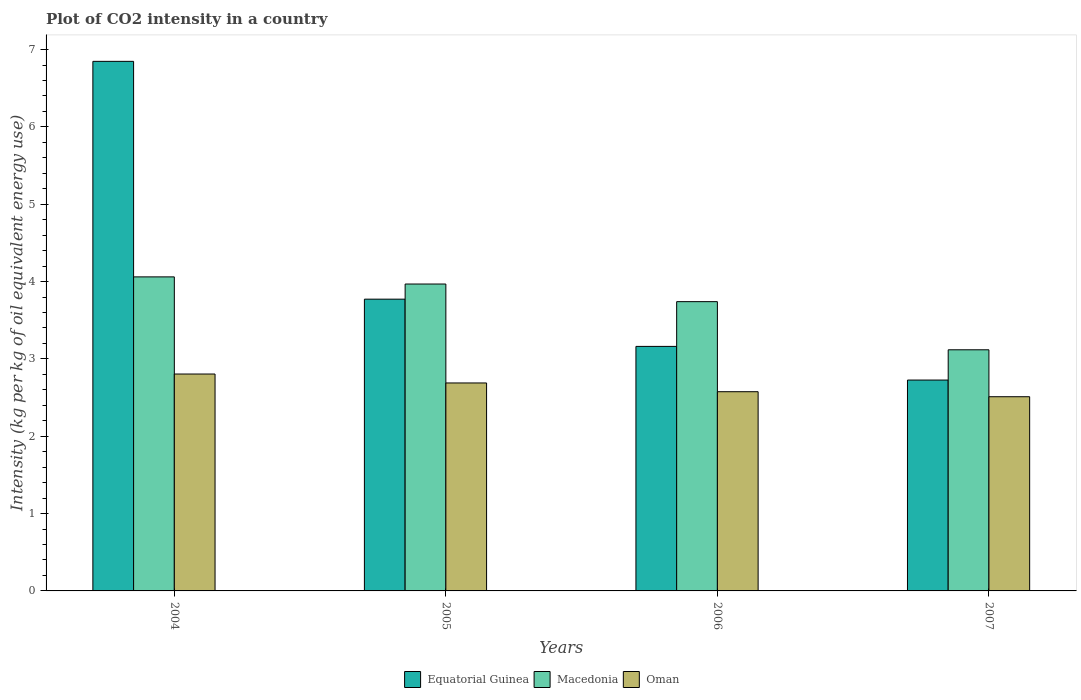How many different coloured bars are there?
Keep it short and to the point. 3. Are the number of bars per tick equal to the number of legend labels?
Your response must be concise. Yes. Are the number of bars on each tick of the X-axis equal?
Make the answer very short. Yes. How many bars are there on the 4th tick from the left?
Provide a succinct answer. 3. What is the CO2 intensity in in Oman in 2007?
Your answer should be compact. 2.51. Across all years, what is the maximum CO2 intensity in in Oman?
Provide a short and direct response. 2.8. Across all years, what is the minimum CO2 intensity in in Macedonia?
Offer a very short reply. 3.12. In which year was the CO2 intensity in in Equatorial Guinea maximum?
Your response must be concise. 2004. What is the total CO2 intensity in in Macedonia in the graph?
Keep it short and to the point. 14.89. What is the difference between the CO2 intensity in in Oman in 2005 and that in 2006?
Offer a terse response. 0.11. What is the difference between the CO2 intensity in in Macedonia in 2007 and the CO2 intensity in in Equatorial Guinea in 2005?
Provide a succinct answer. -0.65. What is the average CO2 intensity in in Oman per year?
Offer a terse response. 2.65. In the year 2007, what is the difference between the CO2 intensity in in Oman and CO2 intensity in in Macedonia?
Your answer should be very brief. -0.61. In how many years, is the CO2 intensity in in Oman greater than 6.8 kg?
Offer a very short reply. 0. What is the ratio of the CO2 intensity in in Equatorial Guinea in 2005 to that in 2006?
Your answer should be compact. 1.19. What is the difference between the highest and the second highest CO2 intensity in in Macedonia?
Keep it short and to the point. 0.09. What is the difference between the highest and the lowest CO2 intensity in in Macedonia?
Ensure brevity in your answer.  0.94. What does the 3rd bar from the left in 2005 represents?
Give a very brief answer. Oman. What does the 3rd bar from the right in 2004 represents?
Make the answer very short. Equatorial Guinea. How many bars are there?
Give a very brief answer. 12. Are all the bars in the graph horizontal?
Your answer should be compact. No. How many years are there in the graph?
Make the answer very short. 4. What is the difference between two consecutive major ticks on the Y-axis?
Offer a very short reply. 1. Does the graph contain grids?
Make the answer very short. No. How many legend labels are there?
Offer a terse response. 3. How are the legend labels stacked?
Your response must be concise. Horizontal. What is the title of the graph?
Your response must be concise. Plot of CO2 intensity in a country. What is the label or title of the Y-axis?
Your answer should be very brief. Intensity (kg per kg of oil equivalent energy use). What is the Intensity (kg per kg of oil equivalent energy use) of Equatorial Guinea in 2004?
Offer a terse response. 6.85. What is the Intensity (kg per kg of oil equivalent energy use) of Macedonia in 2004?
Provide a short and direct response. 4.06. What is the Intensity (kg per kg of oil equivalent energy use) of Oman in 2004?
Make the answer very short. 2.8. What is the Intensity (kg per kg of oil equivalent energy use) of Equatorial Guinea in 2005?
Offer a very short reply. 3.77. What is the Intensity (kg per kg of oil equivalent energy use) in Macedonia in 2005?
Ensure brevity in your answer.  3.97. What is the Intensity (kg per kg of oil equivalent energy use) in Oman in 2005?
Provide a short and direct response. 2.69. What is the Intensity (kg per kg of oil equivalent energy use) of Equatorial Guinea in 2006?
Offer a terse response. 3.16. What is the Intensity (kg per kg of oil equivalent energy use) of Macedonia in 2006?
Your response must be concise. 3.74. What is the Intensity (kg per kg of oil equivalent energy use) of Oman in 2006?
Your answer should be compact. 2.58. What is the Intensity (kg per kg of oil equivalent energy use) of Equatorial Guinea in 2007?
Offer a very short reply. 2.73. What is the Intensity (kg per kg of oil equivalent energy use) of Macedonia in 2007?
Give a very brief answer. 3.12. What is the Intensity (kg per kg of oil equivalent energy use) of Oman in 2007?
Make the answer very short. 2.51. Across all years, what is the maximum Intensity (kg per kg of oil equivalent energy use) in Equatorial Guinea?
Ensure brevity in your answer.  6.85. Across all years, what is the maximum Intensity (kg per kg of oil equivalent energy use) of Macedonia?
Offer a terse response. 4.06. Across all years, what is the maximum Intensity (kg per kg of oil equivalent energy use) of Oman?
Ensure brevity in your answer.  2.8. Across all years, what is the minimum Intensity (kg per kg of oil equivalent energy use) in Equatorial Guinea?
Provide a succinct answer. 2.73. Across all years, what is the minimum Intensity (kg per kg of oil equivalent energy use) of Macedonia?
Your answer should be compact. 3.12. Across all years, what is the minimum Intensity (kg per kg of oil equivalent energy use) of Oman?
Your response must be concise. 2.51. What is the total Intensity (kg per kg of oil equivalent energy use) of Equatorial Guinea in the graph?
Your answer should be very brief. 16.51. What is the total Intensity (kg per kg of oil equivalent energy use) in Macedonia in the graph?
Keep it short and to the point. 14.89. What is the total Intensity (kg per kg of oil equivalent energy use) of Oman in the graph?
Your answer should be compact. 10.58. What is the difference between the Intensity (kg per kg of oil equivalent energy use) of Equatorial Guinea in 2004 and that in 2005?
Offer a very short reply. 3.08. What is the difference between the Intensity (kg per kg of oil equivalent energy use) of Macedonia in 2004 and that in 2005?
Keep it short and to the point. 0.09. What is the difference between the Intensity (kg per kg of oil equivalent energy use) of Oman in 2004 and that in 2005?
Ensure brevity in your answer.  0.12. What is the difference between the Intensity (kg per kg of oil equivalent energy use) in Equatorial Guinea in 2004 and that in 2006?
Your response must be concise. 3.69. What is the difference between the Intensity (kg per kg of oil equivalent energy use) of Macedonia in 2004 and that in 2006?
Keep it short and to the point. 0.32. What is the difference between the Intensity (kg per kg of oil equivalent energy use) in Oman in 2004 and that in 2006?
Your answer should be compact. 0.23. What is the difference between the Intensity (kg per kg of oil equivalent energy use) in Equatorial Guinea in 2004 and that in 2007?
Provide a succinct answer. 4.12. What is the difference between the Intensity (kg per kg of oil equivalent energy use) in Macedonia in 2004 and that in 2007?
Provide a short and direct response. 0.94. What is the difference between the Intensity (kg per kg of oil equivalent energy use) of Oman in 2004 and that in 2007?
Keep it short and to the point. 0.29. What is the difference between the Intensity (kg per kg of oil equivalent energy use) in Equatorial Guinea in 2005 and that in 2006?
Ensure brevity in your answer.  0.61. What is the difference between the Intensity (kg per kg of oil equivalent energy use) of Macedonia in 2005 and that in 2006?
Provide a short and direct response. 0.23. What is the difference between the Intensity (kg per kg of oil equivalent energy use) of Oman in 2005 and that in 2006?
Provide a succinct answer. 0.11. What is the difference between the Intensity (kg per kg of oil equivalent energy use) in Equatorial Guinea in 2005 and that in 2007?
Offer a very short reply. 1.05. What is the difference between the Intensity (kg per kg of oil equivalent energy use) in Macedonia in 2005 and that in 2007?
Provide a short and direct response. 0.85. What is the difference between the Intensity (kg per kg of oil equivalent energy use) of Oman in 2005 and that in 2007?
Offer a terse response. 0.18. What is the difference between the Intensity (kg per kg of oil equivalent energy use) of Equatorial Guinea in 2006 and that in 2007?
Keep it short and to the point. 0.44. What is the difference between the Intensity (kg per kg of oil equivalent energy use) in Macedonia in 2006 and that in 2007?
Your answer should be very brief. 0.62. What is the difference between the Intensity (kg per kg of oil equivalent energy use) in Oman in 2006 and that in 2007?
Your answer should be compact. 0.06. What is the difference between the Intensity (kg per kg of oil equivalent energy use) of Equatorial Guinea in 2004 and the Intensity (kg per kg of oil equivalent energy use) of Macedonia in 2005?
Provide a short and direct response. 2.88. What is the difference between the Intensity (kg per kg of oil equivalent energy use) of Equatorial Guinea in 2004 and the Intensity (kg per kg of oil equivalent energy use) of Oman in 2005?
Offer a very short reply. 4.16. What is the difference between the Intensity (kg per kg of oil equivalent energy use) in Macedonia in 2004 and the Intensity (kg per kg of oil equivalent energy use) in Oman in 2005?
Give a very brief answer. 1.37. What is the difference between the Intensity (kg per kg of oil equivalent energy use) in Equatorial Guinea in 2004 and the Intensity (kg per kg of oil equivalent energy use) in Macedonia in 2006?
Offer a terse response. 3.11. What is the difference between the Intensity (kg per kg of oil equivalent energy use) in Equatorial Guinea in 2004 and the Intensity (kg per kg of oil equivalent energy use) in Oman in 2006?
Keep it short and to the point. 4.27. What is the difference between the Intensity (kg per kg of oil equivalent energy use) in Macedonia in 2004 and the Intensity (kg per kg of oil equivalent energy use) in Oman in 2006?
Offer a very short reply. 1.48. What is the difference between the Intensity (kg per kg of oil equivalent energy use) in Equatorial Guinea in 2004 and the Intensity (kg per kg of oil equivalent energy use) in Macedonia in 2007?
Make the answer very short. 3.73. What is the difference between the Intensity (kg per kg of oil equivalent energy use) in Equatorial Guinea in 2004 and the Intensity (kg per kg of oil equivalent energy use) in Oman in 2007?
Keep it short and to the point. 4.34. What is the difference between the Intensity (kg per kg of oil equivalent energy use) of Macedonia in 2004 and the Intensity (kg per kg of oil equivalent energy use) of Oman in 2007?
Make the answer very short. 1.55. What is the difference between the Intensity (kg per kg of oil equivalent energy use) of Equatorial Guinea in 2005 and the Intensity (kg per kg of oil equivalent energy use) of Macedonia in 2006?
Ensure brevity in your answer.  0.03. What is the difference between the Intensity (kg per kg of oil equivalent energy use) in Equatorial Guinea in 2005 and the Intensity (kg per kg of oil equivalent energy use) in Oman in 2006?
Keep it short and to the point. 1.2. What is the difference between the Intensity (kg per kg of oil equivalent energy use) in Macedonia in 2005 and the Intensity (kg per kg of oil equivalent energy use) in Oman in 2006?
Your answer should be compact. 1.39. What is the difference between the Intensity (kg per kg of oil equivalent energy use) of Equatorial Guinea in 2005 and the Intensity (kg per kg of oil equivalent energy use) of Macedonia in 2007?
Provide a short and direct response. 0.65. What is the difference between the Intensity (kg per kg of oil equivalent energy use) in Equatorial Guinea in 2005 and the Intensity (kg per kg of oil equivalent energy use) in Oman in 2007?
Make the answer very short. 1.26. What is the difference between the Intensity (kg per kg of oil equivalent energy use) in Macedonia in 2005 and the Intensity (kg per kg of oil equivalent energy use) in Oman in 2007?
Offer a very short reply. 1.46. What is the difference between the Intensity (kg per kg of oil equivalent energy use) in Equatorial Guinea in 2006 and the Intensity (kg per kg of oil equivalent energy use) in Macedonia in 2007?
Make the answer very short. 0.04. What is the difference between the Intensity (kg per kg of oil equivalent energy use) of Equatorial Guinea in 2006 and the Intensity (kg per kg of oil equivalent energy use) of Oman in 2007?
Your answer should be very brief. 0.65. What is the difference between the Intensity (kg per kg of oil equivalent energy use) of Macedonia in 2006 and the Intensity (kg per kg of oil equivalent energy use) of Oman in 2007?
Your answer should be compact. 1.23. What is the average Intensity (kg per kg of oil equivalent energy use) of Equatorial Guinea per year?
Your answer should be very brief. 4.13. What is the average Intensity (kg per kg of oil equivalent energy use) of Macedonia per year?
Offer a very short reply. 3.72. What is the average Intensity (kg per kg of oil equivalent energy use) in Oman per year?
Make the answer very short. 2.65. In the year 2004, what is the difference between the Intensity (kg per kg of oil equivalent energy use) of Equatorial Guinea and Intensity (kg per kg of oil equivalent energy use) of Macedonia?
Give a very brief answer. 2.79. In the year 2004, what is the difference between the Intensity (kg per kg of oil equivalent energy use) of Equatorial Guinea and Intensity (kg per kg of oil equivalent energy use) of Oman?
Keep it short and to the point. 4.04. In the year 2004, what is the difference between the Intensity (kg per kg of oil equivalent energy use) of Macedonia and Intensity (kg per kg of oil equivalent energy use) of Oman?
Make the answer very short. 1.26. In the year 2005, what is the difference between the Intensity (kg per kg of oil equivalent energy use) in Equatorial Guinea and Intensity (kg per kg of oil equivalent energy use) in Macedonia?
Your answer should be very brief. -0.2. In the year 2005, what is the difference between the Intensity (kg per kg of oil equivalent energy use) in Equatorial Guinea and Intensity (kg per kg of oil equivalent energy use) in Oman?
Your answer should be very brief. 1.08. In the year 2005, what is the difference between the Intensity (kg per kg of oil equivalent energy use) in Macedonia and Intensity (kg per kg of oil equivalent energy use) in Oman?
Make the answer very short. 1.28. In the year 2006, what is the difference between the Intensity (kg per kg of oil equivalent energy use) in Equatorial Guinea and Intensity (kg per kg of oil equivalent energy use) in Macedonia?
Your answer should be very brief. -0.58. In the year 2006, what is the difference between the Intensity (kg per kg of oil equivalent energy use) in Equatorial Guinea and Intensity (kg per kg of oil equivalent energy use) in Oman?
Provide a succinct answer. 0.59. In the year 2006, what is the difference between the Intensity (kg per kg of oil equivalent energy use) in Macedonia and Intensity (kg per kg of oil equivalent energy use) in Oman?
Provide a succinct answer. 1.16. In the year 2007, what is the difference between the Intensity (kg per kg of oil equivalent energy use) in Equatorial Guinea and Intensity (kg per kg of oil equivalent energy use) in Macedonia?
Provide a short and direct response. -0.39. In the year 2007, what is the difference between the Intensity (kg per kg of oil equivalent energy use) of Equatorial Guinea and Intensity (kg per kg of oil equivalent energy use) of Oman?
Your answer should be very brief. 0.22. In the year 2007, what is the difference between the Intensity (kg per kg of oil equivalent energy use) of Macedonia and Intensity (kg per kg of oil equivalent energy use) of Oman?
Offer a terse response. 0.61. What is the ratio of the Intensity (kg per kg of oil equivalent energy use) in Equatorial Guinea in 2004 to that in 2005?
Your answer should be compact. 1.82. What is the ratio of the Intensity (kg per kg of oil equivalent energy use) of Macedonia in 2004 to that in 2005?
Your answer should be compact. 1.02. What is the ratio of the Intensity (kg per kg of oil equivalent energy use) in Oman in 2004 to that in 2005?
Your answer should be very brief. 1.04. What is the ratio of the Intensity (kg per kg of oil equivalent energy use) of Equatorial Guinea in 2004 to that in 2006?
Keep it short and to the point. 2.17. What is the ratio of the Intensity (kg per kg of oil equivalent energy use) of Macedonia in 2004 to that in 2006?
Keep it short and to the point. 1.09. What is the ratio of the Intensity (kg per kg of oil equivalent energy use) of Oman in 2004 to that in 2006?
Your answer should be compact. 1.09. What is the ratio of the Intensity (kg per kg of oil equivalent energy use) in Equatorial Guinea in 2004 to that in 2007?
Keep it short and to the point. 2.51. What is the ratio of the Intensity (kg per kg of oil equivalent energy use) of Macedonia in 2004 to that in 2007?
Offer a very short reply. 1.3. What is the ratio of the Intensity (kg per kg of oil equivalent energy use) of Oman in 2004 to that in 2007?
Your answer should be compact. 1.12. What is the ratio of the Intensity (kg per kg of oil equivalent energy use) in Equatorial Guinea in 2005 to that in 2006?
Offer a very short reply. 1.19. What is the ratio of the Intensity (kg per kg of oil equivalent energy use) in Macedonia in 2005 to that in 2006?
Give a very brief answer. 1.06. What is the ratio of the Intensity (kg per kg of oil equivalent energy use) of Oman in 2005 to that in 2006?
Your answer should be very brief. 1.04. What is the ratio of the Intensity (kg per kg of oil equivalent energy use) in Equatorial Guinea in 2005 to that in 2007?
Ensure brevity in your answer.  1.38. What is the ratio of the Intensity (kg per kg of oil equivalent energy use) of Macedonia in 2005 to that in 2007?
Provide a succinct answer. 1.27. What is the ratio of the Intensity (kg per kg of oil equivalent energy use) of Oman in 2005 to that in 2007?
Your answer should be very brief. 1.07. What is the ratio of the Intensity (kg per kg of oil equivalent energy use) of Equatorial Guinea in 2006 to that in 2007?
Ensure brevity in your answer.  1.16. What is the ratio of the Intensity (kg per kg of oil equivalent energy use) of Macedonia in 2006 to that in 2007?
Provide a short and direct response. 1.2. What is the ratio of the Intensity (kg per kg of oil equivalent energy use) in Oman in 2006 to that in 2007?
Make the answer very short. 1.03. What is the difference between the highest and the second highest Intensity (kg per kg of oil equivalent energy use) of Equatorial Guinea?
Offer a very short reply. 3.08. What is the difference between the highest and the second highest Intensity (kg per kg of oil equivalent energy use) in Macedonia?
Keep it short and to the point. 0.09. What is the difference between the highest and the second highest Intensity (kg per kg of oil equivalent energy use) of Oman?
Keep it short and to the point. 0.12. What is the difference between the highest and the lowest Intensity (kg per kg of oil equivalent energy use) in Equatorial Guinea?
Your answer should be very brief. 4.12. What is the difference between the highest and the lowest Intensity (kg per kg of oil equivalent energy use) of Macedonia?
Ensure brevity in your answer.  0.94. What is the difference between the highest and the lowest Intensity (kg per kg of oil equivalent energy use) of Oman?
Your response must be concise. 0.29. 